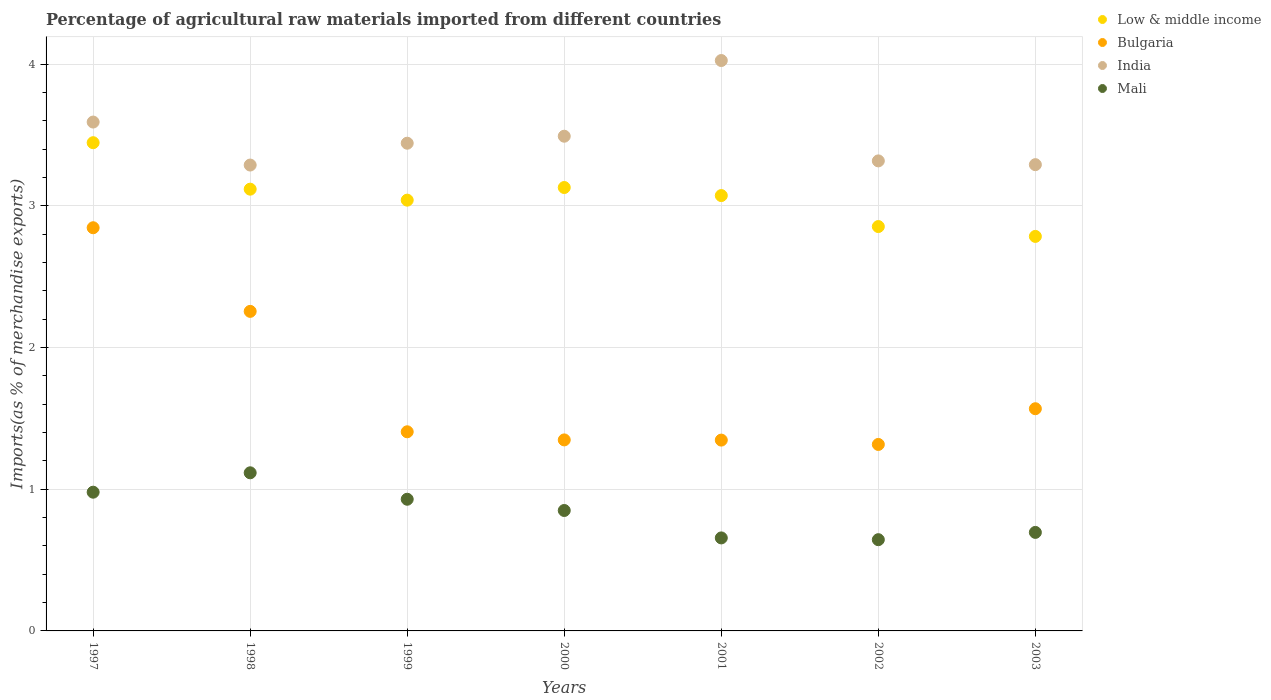Is the number of dotlines equal to the number of legend labels?
Make the answer very short. Yes. What is the percentage of imports to different countries in Bulgaria in 2001?
Your answer should be compact. 1.35. Across all years, what is the maximum percentage of imports to different countries in Mali?
Your answer should be very brief. 1.12. Across all years, what is the minimum percentage of imports to different countries in Bulgaria?
Give a very brief answer. 1.32. What is the total percentage of imports to different countries in Bulgaria in the graph?
Provide a short and direct response. 12.09. What is the difference between the percentage of imports to different countries in Mali in 2000 and that in 2001?
Keep it short and to the point. 0.19. What is the difference between the percentage of imports to different countries in Mali in 1999 and the percentage of imports to different countries in Low & middle income in 2000?
Ensure brevity in your answer.  -2.2. What is the average percentage of imports to different countries in India per year?
Your answer should be compact. 3.49. In the year 2001, what is the difference between the percentage of imports to different countries in India and percentage of imports to different countries in Bulgaria?
Your answer should be compact. 2.68. In how many years, is the percentage of imports to different countries in India greater than 0.2 %?
Offer a very short reply. 7. What is the ratio of the percentage of imports to different countries in Mali in 1997 to that in 1998?
Offer a very short reply. 0.88. Is the percentage of imports to different countries in India in 1997 less than that in 2001?
Keep it short and to the point. Yes. What is the difference between the highest and the second highest percentage of imports to different countries in Bulgaria?
Make the answer very short. 0.59. What is the difference between the highest and the lowest percentage of imports to different countries in Mali?
Offer a terse response. 0.47. In how many years, is the percentage of imports to different countries in Bulgaria greater than the average percentage of imports to different countries in Bulgaria taken over all years?
Your answer should be compact. 2. Is the sum of the percentage of imports to different countries in Mali in 1999 and 2000 greater than the maximum percentage of imports to different countries in India across all years?
Offer a very short reply. No. Is it the case that in every year, the sum of the percentage of imports to different countries in India and percentage of imports to different countries in Mali  is greater than the sum of percentage of imports to different countries in Low & middle income and percentage of imports to different countries in Bulgaria?
Your response must be concise. No. Is it the case that in every year, the sum of the percentage of imports to different countries in Bulgaria and percentage of imports to different countries in India  is greater than the percentage of imports to different countries in Mali?
Your answer should be very brief. Yes. Is the percentage of imports to different countries in Bulgaria strictly greater than the percentage of imports to different countries in Mali over the years?
Offer a very short reply. Yes. How many years are there in the graph?
Offer a terse response. 7. What is the difference between two consecutive major ticks on the Y-axis?
Make the answer very short. 1. Does the graph contain any zero values?
Keep it short and to the point. No. Where does the legend appear in the graph?
Offer a very short reply. Top right. How many legend labels are there?
Keep it short and to the point. 4. What is the title of the graph?
Your answer should be very brief. Percentage of agricultural raw materials imported from different countries. What is the label or title of the Y-axis?
Make the answer very short. Imports(as % of merchandise exports). What is the Imports(as % of merchandise exports) in Low & middle income in 1997?
Make the answer very short. 3.45. What is the Imports(as % of merchandise exports) of Bulgaria in 1997?
Keep it short and to the point. 2.85. What is the Imports(as % of merchandise exports) of India in 1997?
Your response must be concise. 3.59. What is the Imports(as % of merchandise exports) of Mali in 1997?
Your answer should be very brief. 0.98. What is the Imports(as % of merchandise exports) in Low & middle income in 1998?
Make the answer very short. 3.12. What is the Imports(as % of merchandise exports) in Bulgaria in 1998?
Keep it short and to the point. 2.26. What is the Imports(as % of merchandise exports) of India in 1998?
Make the answer very short. 3.29. What is the Imports(as % of merchandise exports) in Mali in 1998?
Give a very brief answer. 1.12. What is the Imports(as % of merchandise exports) in Low & middle income in 1999?
Your answer should be compact. 3.04. What is the Imports(as % of merchandise exports) in Bulgaria in 1999?
Offer a very short reply. 1.41. What is the Imports(as % of merchandise exports) of India in 1999?
Give a very brief answer. 3.44. What is the Imports(as % of merchandise exports) of Mali in 1999?
Make the answer very short. 0.93. What is the Imports(as % of merchandise exports) in Low & middle income in 2000?
Your answer should be very brief. 3.13. What is the Imports(as % of merchandise exports) in Bulgaria in 2000?
Provide a succinct answer. 1.35. What is the Imports(as % of merchandise exports) in India in 2000?
Your answer should be compact. 3.49. What is the Imports(as % of merchandise exports) in Mali in 2000?
Offer a terse response. 0.85. What is the Imports(as % of merchandise exports) of Low & middle income in 2001?
Your answer should be very brief. 3.07. What is the Imports(as % of merchandise exports) of Bulgaria in 2001?
Make the answer very short. 1.35. What is the Imports(as % of merchandise exports) in India in 2001?
Make the answer very short. 4.03. What is the Imports(as % of merchandise exports) in Mali in 2001?
Make the answer very short. 0.66. What is the Imports(as % of merchandise exports) in Low & middle income in 2002?
Offer a terse response. 2.85. What is the Imports(as % of merchandise exports) of Bulgaria in 2002?
Offer a terse response. 1.32. What is the Imports(as % of merchandise exports) in India in 2002?
Give a very brief answer. 3.32. What is the Imports(as % of merchandise exports) in Mali in 2002?
Make the answer very short. 0.64. What is the Imports(as % of merchandise exports) of Low & middle income in 2003?
Offer a very short reply. 2.78. What is the Imports(as % of merchandise exports) in Bulgaria in 2003?
Your answer should be compact. 1.57. What is the Imports(as % of merchandise exports) of India in 2003?
Your response must be concise. 3.29. What is the Imports(as % of merchandise exports) in Mali in 2003?
Your answer should be very brief. 0.7. Across all years, what is the maximum Imports(as % of merchandise exports) in Low & middle income?
Offer a very short reply. 3.45. Across all years, what is the maximum Imports(as % of merchandise exports) of Bulgaria?
Provide a short and direct response. 2.85. Across all years, what is the maximum Imports(as % of merchandise exports) in India?
Your answer should be compact. 4.03. Across all years, what is the maximum Imports(as % of merchandise exports) of Mali?
Offer a very short reply. 1.12. Across all years, what is the minimum Imports(as % of merchandise exports) of Low & middle income?
Provide a succinct answer. 2.78. Across all years, what is the minimum Imports(as % of merchandise exports) in Bulgaria?
Ensure brevity in your answer.  1.32. Across all years, what is the minimum Imports(as % of merchandise exports) in India?
Provide a short and direct response. 3.29. Across all years, what is the minimum Imports(as % of merchandise exports) in Mali?
Offer a terse response. 0.64. What is the total Imports(as % of merchandise exports) in Low & middle income in the graph?
Your answer should be very brief. 21.45. What is the total Imports(as % of merchandise exports) in Bulgaria in the graph?
Offer a terse response. 12.09. What is the total Imports(as % of merchandise exports) of India in the graph?
Give a very brief answer. 24.45. What is the total Imports(as % of merchandise exports) of Mali in the graph?
Make the answer very short. 5.87. What is the difference between the Imports(as % of merchandise exports) of Low & middle income in 1997 and that in 1998?
Your answer should be very brief. 0.33. What is the difference between the Imports(as % of merchandise exports) in Bulgaria in 1997 and that in 1998?
Your answer should be very brief. 0.59. What is the difference between the Imports(as % of merchandise exports) of India in 1997 and that in 1998?
Give a very brief answer. 0.3. What is the difference between the Imports(as % of merchandise exports) in Mali in 1997 and that in 1998?
Offer a very short reply. -0.14. What is the difference between the Imports(as % of merchandise exports) in Low & middle income in 1997 and that in 1999?
Your response must be concise. 0.41. What is the difference between the Imports(as % of merchandise exports) in Bulgaria in 1997 and that in 1999?
Make the answer very short. 1.44. What is the difference between the Imports(as % of merchandise exports) of India in 1997 and that in 1999?
Give a very brief answer. 0.15. What is the difference between the Imports(as % of merchandise exports) of Mali in 1997 and that in 1999?
Keep it short and to the point. 0.05. What is the difference between the Imports(as % of merchandise exports) in Low & middle income in 1997 and that in 2000?
Your answer should be very brief. 0.32. What is the difference between the Imports(as % of merchandise exports) in Bulgaria in 1997 and that in 2000?
Make the answer very short. 1.5. What is the difference between the Imports(as % of merchandise exports) of India in 1997 and that in 2000?
Make the answer very short. 0.1. What is the difference between the Imports(as % of merchandise exports) of Mali in 1997 and that in 2000?
Keep it short and to the point. 0.13. What is the difference between the Imports(as % of merchandise exports) in Low & middle income in 1997 and that in 2001?
Your answer should be very brief. 0.37. What is the difference between the Imports(as % of merchandise exports) of Bulgaria in 1997 and that in 2001?
Your answer should be very brief. 1.5. What is the difference between the Imports(as % of merchandise exports) of India in 1997 and that in 2001?
Your answer should be compact. -0.43. What is the difference between the Imports(as % of merchandise exports) in Mali in 1997 and that in 2001?
Offer a very short reply. 0.32. What is the difference between the Imports(as % of merchandise exports) of Low & middle income in 1997 and that in 2002?
Give a very brief answer. 0.59. What is the difference between the Imports(as % of merchandise exports) in Bulgaria in 1997 and that in 2002?
Keep it short and to the point. 1.53. What is the difference between the Imports(as % of merchandise exports) in India in 1997 and that in 2002?
Your answer should be compact. 0.27. What is the difference between the Imports(as % of merchandise exports) in Mali in 1997 and that in 2002?
Offer a very short reply. 0.34. What is the difference between the Imports(as % of merchandise exports) in Low & middle income in 1997 and that in 2003?
Offer a very short reply. 0.66. What is the difference between the Imports(as % of merchandise exports) of Bulgaria in 1997 and that in 2003?
Offer a very short reply. 1.28. What is the difference between the Imports(as % of merchandise exports) in India in 1997 and that in 2003?
Offer a terse response. 0.3. What is the difference between the Imports(as % of merchandise exports) of Mali in 1997 and that in 2003?
Offer a very short reply. 0.28. What is the difference between the Imports(as % of merchandise exports) of Low & middle income in 1998 and that in 1999?
Provide a succinct answer. 0.08. What is the difference between the Imports(as % of merchandise exports) of Bulgaria in 1998 and that in 1999?
Offer a terse response. 0.85. What is the difference between the Imports(as % of merchandise exports) of India in 1998 and that in 1999?
Provide a short and direct response. -0.15. What is the difference between the Imports(as % of merchandise exports) of Mali in 1998 and that in 1999?
Offer a terse response. 0.19. What is the difference between the Imports(as % of merchandise exports) in Low & middle income in 1998 and that in 2000?
Your answer should be compact. -0.01. What is the difference between the Imports(as % of merchandise exports) in Bulgaria in 1998 and that in 2000?
Provide a short and direct response. 0.91. What is the difference between the Imports(as % of merchandise exports) of India in 1998 and that in 2000?
Offer a very short reply. -0.2. What is the difference between the Imports(as % of merchandise exports) of Mali in 1998 and that in 2000?
Ensure brevity in your answer.  0.27. What is the difference between the Imports(as % of merchandise exports) in Low & middle income in 1998 and that in 2001?
Provide a succinct answer. 0.05. What is the difference between the Imports(as % of merchandise exports) of Bulgaria in 1998 and that in 2001?
Your answer should be compact. 0.91. What is the difference between the Imports(as % of merchandise exports) of India in 1998 and that in 2001?
Offer a very short reply. -0.74. What is the difference between the Imports(as % of merchandise exports) in Mali in 1998 and that in 2001?
Provide a succinct answer. 0.46. What is the difference between the Imports(as % of merchandise exports) in Low & middle income in 1998 and that in 2002?
Ensure brevity in your answer.  0.26. What is the difference between the Imports(as % of merchandise exports) in Bulgaria in 1998 and that in 2002?
Your answer should be very brief. 0.94. What is the difference between the Imports(as % of merchandise exports) in India in 1998 and that in 2002?
Your answer should be very brief. -0.03. What is the difference between the Imports(as % of merchandise exports) of Mali in 1998 and that in 2002?
Offer a terse response. 0.47. What is the difference between the Imports(as % of merchandise exports) of Low & middle income in 1998 and that in 2003?
Offer a very short reply. 0.33. What is the difference between the Imports(as % of merchandise exports) of Bulgaria in 1998 and that in 2003?
Offer a very short reply. 0.69. What is the difference between the Imports(as % of merchandise exports) in India in 1998 and that in 2003?
Give a very brief answer. -0. What is the difference between the Imports(as % of merchandise exports) of Mali in 1998 and that in 2003?
Your response must be concise. 0.42. What is the difference between the Imports(as % of merchandise exports) of Low & middle income in 1999 and that in 2000?
Your answer should be very brief. -0.09. What is the difference between the Imports(as % of merchandise exports) of Bulgaria in 1999 and that in 2000?
Keep it short and to the point. 0.06. What is the difference between the Imports(as % of merchandise exports) of India in 1999 and that in 2000?
Your answer should be compact. -0.05. What is the difference between the Imports(as % of merchandise exports) of Mali in 1999 and that in 2000?
Your response must be concise. 0.08. What is the difference between the Imports(as % of merchandise exports) in Low & middle income in 1999 and that in 2001?
Ensure brevity in your answer.  -0.03. What is the difference between the Imports(as % of merchandise exports) of Bulgaria in 1999 and that in 2001?
Offer a very short reply. 0.06. What is the difference between the Imports(as % of merchandise exports) in India in 1999 and that in 2001?
Provide a succinct answer. -0.58. What is the difference between the Imports(as % of merchandise exports) of Mali in 1999 and that in 2001?
Give a very brief answer. 0.27. What is the difference between the Imports(as % of merchandise exports) in Low & middle income in 1999 and that in 2002?
Offer a very short reply. 0.19. What is the difference between the Imports(as % of merchandise exports) in Bulgaria in 1999 and that in 2002?
Ensure brevity in your answer.  0.09. What is the difference between the Imports(as % of merchandise exports) of India in 1999 and that in 2002?
Your answer should be very brief. 0.12. What is the difference between the Imports(as % of merchandise exports) of Mali in 1999 and that in 2002?
Provide a succinct answer. 0.29. What is the difference between the Imports(as % of merchandise exports) of Low & middle income in 1999 and that in 2003?
Provide a succinct answer. 0.26. What is the difference between the Imports(as % of merchandise exports) in Bulgaria in 1999 and that in 2003?
Your answer should be compact. -0.16. What is the difference between the Imports(as % of merchandise exports) in India in 1999 and that in 2003?
Your answer should be compact. 0.15. What is the difference between the Imports(as % of merchandise exports) in Mali in 1999 and that in 2003?
Keep it short and to the point. 0.23. What is the difference between the Imports(as % of merchandise exports) of Low & middle income in 2000 and that in 2001?
Your answer should be compact. 0.06. What is the difference between the Imports(as % of merchandise exports) of Bulgaria in 2000 and that in 2001?
Make the answer very short. 0. What is the difference between the Imports(as % of merchandise exports) in India in 2000 and that in 2001?
Your response must be concise. -0.53. What is the difference between the Imports(as % of merchandise exports) in Mali in 2000 and that in 2001?
Make the answer very short. 0.19. What is the difference between the Imports(as % of merchandise exports) of Low & middle income in 2000 and that in 2002?
Ensure brevity in your answer.  0.28. What is the difference between the Imports(as % of merchandise exports) in Bulgaria in 2000 and that in 2002?
Make the answer very short. 0.03. What is the difference between the Imports(as % of merchandise exports) of India in 2000 and that in 2002?
Your answer should be very brief. 0.17. What is the difference between the Imports(as % of merchandise exports) of Mali in 2000 and that in 2002?
Make the answer very short. 0.21. What is the difference between the Imports(as % of merchandise exports) in Low & middle income in 2000 and that in 2003?
Give a very brief answer. 0.35. What is the difference between the Imports(as % of merchandise exports) of Bulgaria in 2000 and that in 2003?
Keep it short and to the point. -0.22. What is the difference between the Imports(as % of merchandise exports) in India in 2000 and that in 2003?
Offer a terse response. 0.2. What is the difference between the Imports(as % of merchandise exports) of Mali in 2000 and that in 2003?
Give a very brief answer. 0.15. What is the difference between the Imports(as % of merchandise exports) in Low & middle income in 2001 and that in 2002?
Give a very brief answer. 0.22. What is the difference between the Imports(as % of merchandise exports) of Bulgaria in 2001 and that in 2002?
Offer a very short reply. 0.03. What is the difference between the Imports(as % of merchandise exports) of India in 2001 and that in 2002?
Your response must be concise. 0.71. What is the difference between the Imports(as % of merchandise exports) of Mali in 2001 and that in 2002?
Keep it short and to the point. 0.01. What is the difference between the Imports(as % of merchandise exports) in Low & middle income in 2001 and that in 2003?
Provide a short and direct response. 0.29. What is the difference between the Imports(as % of merchandise exports) of Bulgaria in 2001 and that in 2003?
Give a very brief answer. -0.22. What is the difference between the Imports(as % of merchandise exports) of India in 2001 and that in 2003?
Offer a very short reply. 0.73. What is the difference between the Imports(as % of merchandise exports) in Mali in 2001 and that in 2003?
Offer a terse response. -0.04. What is the difference between the Imports(as % of merchandise exports) in Low & middle income in 2002 and that in 2003?
Provide a succinct answer. 0.07. What is the difference between the Imports(as % of merchandise exports) of Bulgaria in 2002 and that in 2003?
Give a very brief answer. -0.25. What is the difference between the Imports(as % of merchandise exports) in India in 2002 and that in 2003?
Offer a terse response. 0.03. What is the difference between the Imports(as % of merchandise exports) of Mali in 2002 and that in 2003?
Give a very brief answer. -0.05. What is the difference between the Imports(as % of merchandise exports) of Low & middle income in 1997 and the Imports(as % of merchandise exports) of Bulgaria in 1998?
Your answer should be very brief. 1.19. What is the difference between the Imports(as % of merchandise exports) in Low & middle income in 1997 and the Imports(as % of merchandise exports) in India in 1998?
Make the answer very short. 0.16. What is the difference between the Imports(as % of merchandise exports) of Low & middle income in 1997 and the Imports(as % of merchandise exports) of Mali in 1998?
Offer a terse response. 2.33. What is the difference between the Imports(as % of merchandise exports) in Bulgaria in 1997 and the Imports(as % of merchandise exports) in India in 1998?
Your answer should be compact. -0.44. What is the difference between the Imports(as % of merchandise exports) of Bulgaria in 1997 and the Imports(as % of merchandise exports) of Mali in 1998?
Offer a very short reply. 1.73. What is the difference between the Imports(as % of merchandise exports) in India in 1997 and the Imports(as % of merchandise exports) in Mali in 1998?
Ensure brevity in your answer.  2.48. What is the difference between the Imports(as % of merchandise exports) in Low & middle income in 1997 and the Imports(as % of merchandise exports) in Bulgaria in 1999?
Your answer should be very brief. 2.04. What is the difference between the Imports(as % of merchandise exports) of Low & middle income in 1997 and the Imports(as % of merchandise exports) of India in 1999?
Your answer should be very brief. 0. What is the difference between the Imports(as % of merchandise exports) in Low & middle income in 1997 and the Imports(as % of merchandise exports) in Mali in 1999?
Give a very brief answer. 2.52. What is the difference between the Imports(as % of merchandise exports) in Bulgaria in 1997 and the Imports(as % of merchandise exports) in India in 1999?
Provide a short and direct response. -0.6. What is the difference between the Imports(as % of merchandise exports) of Bulgaria in 1997 and the Imports(as % of merchandise exports) of Mali in 1999?
Provide a short and direct response. 1.92. What is the difference between the Imports(as % of merchandise exports) in India in 1997 and the Imports(as % of merchandise exports) in Mali in 1999?
Your answer should be compact. 2.66. What is the difference between the Imports(as % of merchandise exports) of Low & middle income in 1997 and the Imports(as % of merchandise exports) of Bulgaria in 2000?
Offer a terse response. 2.1. What is the difference between the Imports(as % of merchandise exports) of Low & middle income in 1997 and the Imports(as % of merchandise exports) of India in 2000?
Provide a succinct answer. -0.05. What is the difference between the Imports(as % of merchandise exports) in Low & middle income in 1997 and the Imports(as % of merchandise exports) in Mali in 2000?
Your answer should be very brief. 2.6. What is the difference between the Imports(as % of merchandise exports) of Bulgaria in 1997 and the Imports(as % of merchandise exports) of India in 2000?
Offer a very short reply. -0.65. What is the difference between the Imports(as % of merchandise exports) of Bulgaria in 1997 and the Imports(as % of merchandise exports) of Mali in 2000?
Your answer should be very brief. 2. What is the difference between the Imports(as % of merchandise exports) in India in 1997 and the Imports(as % of merchandise exports) in Mali in 2000?
Provide a succinct answer. 2.74. What is the difference between the Imports(as % of merchandise exports) of Low & middle income in 1997 and the Imports(as % of merchandise exports) of Bulgaria in 2001?
Make the answer very short. 2.1. What is the difference between the Imports(as % of merchandise exports) in Low & middle income in 1997 and the Imports(as % of merchandise exports) in India in 2001?
Provide a short and direct response. -0.58. What is the difference between the Imports(as % of merchandise exports) in Low & middle income in 1997 and the Imports(as % of merchandise exports) in Mali in 2001?
Offer a terse response. 2.79. What is the difference between the Imports(as % of merchandise exports) in Bulgaria in 1997 and the Imports(as % of merchandise exports) in India in 2001?
Offer a very short reply. -1.18. What is the difference between the Imports(as % of merchandise exports) of Bulgaria in 1997 and the Imports(as % of merchandise exports) of Mali in 2001?
Offer a very short reply. 2.19. What is the difference between the Imports(as % of merchandise exports) of India in 1997 and the Imports(as % of merchandise exports) of Mali in 2001?
Your answer should be very brief. 2.94. What is the difference between the Imports(as % of merchandise exports) in Low & middle income in 1997 and the Imports(as % of merchandise exports) in Bulgaria in 2002?
Your answer should be very brief. 2.13. What is the difference between the Imports(as % of merchandise exports) in Low & middle income in 1997 and the Imports(as % of merchandise exports) in India in 2002?
Provide a short and direct response. 0.13. What is the difference between the Imports(as % of merchandise exports) of Low & middle income in 1997 and the Imports(as % of merchandise exports) of Mali in 2002?
Your answer should be compact. 2.8. What is the difference between the Imports(as % of merchandise exports) in Bulgaria in 1997 and the Imports(as % of merchandise exports) in India in 2002?
Offer a very short reply. -0.47. What is the difference between the Imports(as % of merchandise exports) of Bulgaria in 1997 and the Imports(as % of merchandise exports) of Mali in 2002?
Give a very brief answer. 2.2. What is the difference between the Imports(as % of merchandise exports) in India in 1997 and the Imports(as % of merchandise exports) in Mali in 2002?
Provide a succinct answer. 2.95. What is the difference between the Imports(as % of merchandise exports) of Low & middle income in 1997 and the Imports(as % of merchandise exports) of Bulgaria in 2003?
Provide a short and direct response. 1.88. What is the difference between the Imports(as % of merchandise exports) in Low & middle income in 1997 and the Imports(as % of merchandise exports) in India in 2003?
Make the answer very short. 0.16. What is the difference between the Imports(as % of merchandise exports) of Low & middle income in 1997 and the Imports(as % of merchandise exports) of Mali in 2003?
Keep it short and to the point. 2.75. What is the difference between the Imports(as % of merchandise exports) in Bulgaria in 1997 and the Imports(as % of merchandise exports) in India in 2003?
Keep it short and to the point. -0.45. What is the difference between the Imports(as % of merchandise exports) in Bulgaria in 1997 and the Imports(as % of merchandise exports) in Mali in 2003?
Your answer should be compact. 2.15. What is the difference between the Imports(as % of merchandise exports) of India in 1997 and the Imports(as % of merchandise exports) of Mali in 2003?
Provide a short and direct response. 2.9. What is the difference between the Imports(as % of merchandise exports) of Low & middle income in 1998 and the Imports(as % of merchandise exports) of Bulgaria in 1999?
Keep it short and to the point. 1.71. What is the difference between the Imports(as % of merchandise exports) of Low & middle income in 1998 and the Imports(as % of merchandise exports) of India in 1999?
Make the answer very short. -0.32. What is the difference between the Imports(as % of merchandise exports) of Low & middle income in 1998 and the Imports(as % of merchandise exports) of Mali in 1999?
Give a very brief answer. 2.19. What is the difference between the Imports(as % of merchandise exports) in Bulgaria in 1998 and the Imports(as % of merchandise exports) in India in 1999?
Provide a short and direct response. -1.19. What is the difference between the Imports(as % of merchandise exports) of Bulgaria in 1998 and the Imports(as % of merchandise exports) of Mali in 1999?
Your answer should be compact. 1.33. What is the difference between the Imports(as % of merchandise exports) of India in 1998 and the Imports(as % of merchandise exports) of Mali in 1999?
Keep it short and to the point. 2.36. What is the difference between the Imports(as % of merchandise exports) in Low & middle income in 1998 and the Imports(as % of merchandise exports) in Bulgaria in 2000?
Give a very brief answer. 1.77. What is the difference between the Imports(as % of merchandise exports) in Low & middle income in 1998 and the Imports(as % of merchandise exports) in India in 2000?
Offer a terse response. -0.37. What is the difference between the Imports(as % of merchandise exports) in Low & middle income in 1998 and the Imports(as % of merchandise exports) in Mali in 2000?
Make the answer very short. 2.27. What is the difference between the Imports(as % of merchandise exports) in Bulgaria in 1998 and the Imports(as % of merchandise exports) in India in 2000?
Your answer should be very brief. -1.24. What is the difference between the Imports(as % of merchandise exports) in Bulgaria in 1998 and the Imports(as % of merchandise exports) in Mali in 2000?
Your response must be concise. 1.41. What is the difference between the Imports(as % of merchandise exports) of India in 1998 and the Imports(as % of merchandise exports) of Mali in 2000?
Your answer should be very brief. 2.44. What is the difference between the Imports(as % of merchandise exports) in Low & middle income in 1998 and the Imports(as % of merchandise exports) in Bulgaria in 2001?
Your response must be concise. 1.77. What is the difference between the Imports(as % of merchandise exports) of Low & middle income in 1998 and the Imports(as % of merchandise exports) of India in 2001?
Ensure brevity in your answer.  -0.91. What is the difference between the Imports(as % of merchandise exports) of Low & middle income in 1998 and the Imports(as % of merchandise exports) of Mali in 2001?
Your response must be concise. 2.46. What is the difference between the Imports(as % of merchandise exports) of Bulgaria in 1998 and the Imports(as % of merchandise exports) of India in 2001?
Give a very brief answer. -1.77. What is the difference between the Imports(as % of merchandise exports) of Bulgaria in 1998 and the Imports(as % of merchandise exports) of Mali in 2001?
Your answer should be very brief. 1.6. What is the difference between the Imports(as % of merchandise exports) in India in 1998 and the Imports(as % of merchandise exports) in Mali in 2001?
Offer a very short reply. 2.63. What is the difference between the Imports(as % of merchandise exports) of Low & middle income in 1998 and the Imports(as % of merchandise exports) of Bulgaria in 2002?
Make the answer very short. 1.8. What is the difference between the Imports(as % of merchandise exports) of Low & middle income in 1998 and the Imports(as % of merchandise exports) of India in 2002?
Your answer should be very brief. -0.2. What is the difference between the Imports(as % of merchandise exports) in Low & middle income in 1998 and the Imports(as % of merchandise exports) in Mali in 2002?
Provide a short and direct response. 2.47. What is the difference between the Imports(as % of merchandise exports) of Bulgaria in 1998 and the Imports(as % of merchandise exports) of India in 2002?
Make the answer very short. -1.06. What is the difference between the Imports(as % of merchandise exports) of Bulgaria in 1998 and the Imports(as % of merchandise exports) of Mali in 2002?
Offer a terse response. 1.61. What is the difference between the Imports(as % of merchandise exports) of India in 1998 and the Imports(as % of merchandise exports) of Mali in 2002?
Your answer should be very brief. 2.64. What is the difference between the Imports(as % of merchandise exports) of Low & middle income in 1998 and the Imports(as % of merchandise exports) of Bulgaria in 2003?
Make the answer very short. 1.55. What is the difference between the Imports(as % of merchandise exports) of Low & middle income in 1998 and the Imports(as % of merchandise exports) of India in 2003?
Keep it short and to the point. -0.17. What is the difference between the Imports(as % of merchandise exports) in Low & middle income in 1998 and the Imports(as % of merchandise exports) in Mali in 2003?
Your answer should be very brief. 2.42. What is the difference between the Imports(as % of merchandise exports) in Bulgaria in 1998 and the Imports(as % of merchandise exports) in India in 2003?
Provide a short and direct response. -1.04. What is the difference between the Imports(as % of merchandise exports) in Bulgaria in 1998 and the Imports(as % of merchandise exports) in Mali in 2003?
Offer a very short reply. 1.56. What is the difference between the Imports(as % of merchandise exports) in India in 1998 and the Imports(as % of merchandise exports) in Mali in 2003?
Ensure brevity in your answer.  2.59. What is the difference between the Imports(as % of merchandise exports) in Low & middle income in 1999 and the Imports(as % of merchandise exports) in Bulgaria in 2000?
Offer a very short reply. 1.69. What is the difference between the Imports(as % of merchandise exports) in Low & middle income in 1999 and the Imports(as % of merchandise exports) in India in 2000?
Your answer should be compact. -0.45. What is the difference between the Imports(as % of merchandise exports) of Low & middle income in 1999 and the Imports(as % of merchandise exports) of Mali in 2000?
Your answer should be very brief. 2.19. What is the difference between the Imports(as % of merchandise exports) of Bulgaria in 1999 and the Imports(as % of merchandise exports) of India in 2000?
Keep it short and to the point. -2.09. What is the difference between the Imports(as % of merchandise exports) of Bulgaria in 1999 and the Imports(as % of merchandise exports) of Mali in 2000?
Make the answer very short. 0.56. What is the difference between the Imports(as % of merchandise exports) of India in 1999 and the Imports(as % of merchandise exports) of Mali in 2000?
Offer a terse response. 2.59. What is the difference between the Imports(as % of merchandise exports) of Low & middle income in 1999 and the Imports(as % of merchandise exports) of Bulgaria in 2001?
Keep it short and to the point. 1.69. What is the difference between the Imports(as % of merchandise exports) in Low & middle income in 1999 and the Imports(as % of merchandise exports) in India in 2001?
Your answer should be very brief. -0.99. What is the difference between the Imports(as % of merchandise exports) in Low & middle income in 1999 and the Imports(as % of merchandise exports) in Mali in 2001?
Your response must be concise. 2.38. What is the difference between the Imports(as % of merchandise exports) in Bulgaria in 1999 and the Imports(as % of merchandise exports) in India in 2001?
Your answer should be very brief. -2.62. What is the difference between the Imports(as % of merchandise exports) in Bulgaria in 1999 and the Imports(as % of merchandise exports) in Mali in 2001?
Make the answer very short. 0.75. What is the difference between the Imports(as % of merchandise exports) of India in 1999 and the Imports(as % of merchandise exports) of Mali in 2001?
Keep it short and to the point. 2.79. What is the difference between the Imports(as % of merchandise exports) of Low & middle income in 1999 and the Imports(as % of merchandise exports) of Bulgaria in 2002?
Offer a very short reply. 1.72. What is the difference between the Imports(as % of merchandise exports) in Low & middle income in 1999 and the Imports(as % of merchandise exports) in India in 2002?
Your response must be concise. -0.28. What is the difference between the Imports(as % of merchandise exports) of Low & middle income in 1999 and the Imports(as % of merchandise exports) of Mali in 2002?
Ensure brevity in your answer.  2.4. What is the difference between the Imports(as % of merchandise exports) of Bulgaria in 1999 and the Imports(as % of merchandise exports) of India in 2002?
Your answer should be very brief. -1.91. What is the difference between the Imports(as % of merchandise exports) in Bulgaria in 1999 and the Imports(as % of merchandise exports) in Mali in 2002?
Provide a succinct answer. 0.76. What is the difference between the Imports(as % of merchandise exports) in India in 1999 and the Imports(as % of merchandise exports) in Mali in 2002?
Your response must be concise. 2.8. What is the difference between the Imports(as % of merchandise exports) in Low & middle income in 1999 and the Imports(as % of merchandise exports) in Bulgaria in 2003?
Keep it short and to the point. 1.47. What is the difference between the Imports(as % of merchandise exports) in Low & middle income in 1999 and the Imports(as % of merchandise exports) in India in 2003?
Ensure brevity in your answer.  -0.25. What is the difference between the Imports(as % of merchandise exports) of Low & middle income in 1999 and the Imports(as % of merchandise exports) of Mali in 2003?
Your response must be concise. 2.35. What is the difference between the Imports(as % of merchandise exports) of Bulgaria in 1999 and the Imports(as % of merchandise exports) of India in 2003?
Your answer should be compact. -1.89. What is the difference between the Imports(as % of merchandise exports) of Bulgaria in 1999 and the Imports(as % of merchandise exports) of Mali in 2003?
Provide a short and direct response. 0.71. What is the difference between the Imports(as % of merchandise exports) in India in 1999 and the Imports(as % of merchandise exports) in Mali in 2003?
Your answer should be compact. 2.75. What is the difference between the Imports(as % of merchandise exports) in Low & middle income in 2000 and the Imports(as % of merchandise exports) in Bulgaria in 2001?
Provide a short and direct response. 1.78. What is the difference between the Imports(as % of merchandise exports) of Low & middle income in 2000 and the Imports(as % of merchandise exports) of India in 2001?
Provide a short and direct response. -0.9. What is the difference between the Imports(as % of merchandise exports) of Low & middle income in 2000 and the Imports(as % of merchandise exports) of Mali in 2001?
Keep it short and to the point. 2.47. What is the difference between the Imports(as % of merchandise exports) in Bulgaria in 2000 and the Imports(as % of merchandise exports) in India in 2001?
Give a very brief answer. -2.68. What is the difference between the Imports(as % of merchandise exports) of Bulgaria in 2000 and the Imports(as % of merchandise exports) of Mali in 2001?
Make the answer very short. 0.69. What is the difference between the Imports(as % of merchandise exports) of India in 2000 and the Imports(as % of merchandise exports) of Mali in 2001?
Offer a very short reply. 2.84. What is the difference between the Imports(as % of merchandise exports) of Low & middle income in 2000 and the Imports(as % of merchandise exports) of Bulgaria in 2002?
Ensure brevity in your answer.  1.81. What is the difference between the Imports(as % of merchandise exports) in Low & middle income in 2000 and the Imports(as % of merchandise exports) in India in 2002?
Your response must be concise. -0.19. What is the difference between the Imports(as % of merchandise exports) in Low & middle income in 2000 and the Imports(as % of merchandise exports) in Mali in 2002?
Your response must be concise. 2.49. What is the difference between the Imports(as % of merchandise exports) in Bulgaria in 2000 and the Imports(as % of merchandise exports) in India in 2002?
Your answer should be compact. -1.97. What is the difference between the Imports(as % of merchandise exports) in Bulgaria in 2000 and the Imports(as % of merchandise exports) in Mali in 2002?
Offer a terse response. 0.7. What is the difference between the Imports(as % of merchandise exports) of India in 2000 and the Imports(as % of merchandise exports) of Mali in 2002?
Your response must be concise. 2.85. What is the difference between the Imports(as % of merchandise exports) in Low & middle income in 2000 and the Imports(as % of merchandise exports) in Bulgaria in 2003?
Your answer should be compact. 1.56. What is the difference between the Imports(as % of merchandise exports) of Low & middle income in 2000 and the Imports(as % of merchandise exports) of India in 2003?
Your answer should be compact. -0.16. What is the difference between the Imports(as % of merchandise exports) in Low & middle income in 2000 and the Imports(as % of merchandise exports) in Mali in 2003?
Offer a very short reply. 2.43. What is the difference between the Imports(as % of merchandise exports) in Bulgaria in 2000 and the Imports(as % of merchandise exports) in India in 2003?
Offer a very short reply. -1.94. What is the difference between the Imports(as % of merchandise exports) of Bulgaria in 2000 and the Imports(as % of merchandise exports) of Mali in 2003?
Your answer should be very brief. 0.65. What is the difference between the Imports(as % of merchandise exports) of India in 2000 and the Imports(as % of merchandise exports) of Mali in 2003?
Keep it short and to the point. 2.8. What is the difference between the Imports(as % of merchandise exports) of Low & middle income in 2001 and the Imports(as % of merchandise exports) of Bulgaria in 2002?
Provide a short and direct response. 1.76. What is the difference between the Imports(as % of merchandise exports) of Low & middle income in 2001 and the Imports(as % of merchandise exports) of India in 2002?
Your response must be concise. -0.24. What is the difference between the Imports(as % of merchandise exports) in Low & middle income in 2001 and the Imports(as % of merchandise exports) in Mali in 2002?
Ensure brevity in your answer.  2.43. What is the difference between the Imports(as % of merchandise exports) in Bulgaria in 2001 and the Imports(as % of merchandise exports) in India in 2002?
Make the answer very short. -1.97. What is the difference between the Imports(as % of merchandise exports) in Bulgaria in 2001 and the Imports(as % of merchandise exports) in Mali in 2002?
Provide a succinct answer. 0.7. What is the difference between the Imports(as % of merchandise exports) of India in 2001 and the Imports(as % of merchandise exports) of Mali in 2002?
Provide a short and direct response. 3.38. What is the difference between the Imports(as % of merchandise exports) in Low & middle income in 2001 and the Imports(as % of merchandise exports) in Bulgaria in 2003?
Keep it short and to the point. 1.5. What is the difference between the Imports(as % of merchandise exports) in Low & middle income in 2001 and the Imports(as % of merchandise exports) in India in 2003?
Your answer should be compact. -0.22. What is the difference between the Imports(as % of merchandise exports) of Low & middle income in 2001 and the Imports(as % of merchandise exports) of Mali in 2003?
Your answer should be compact. 2.38. What is the difference between the Imports(as % of merchandise exports) of Bulgaria in 2001 and the Imports(as % of merchandise exports) of India in 2003?
Make the answer very short. -1.94. What is the difference between the Imports(as % of merchandise exports) in Bulgaria in 2001 and the Imports(as % of merchandise exports) in Mali in 2003?
Keep it short and to the point. 0.65. What is the difference between the Imports(as % of merchandise exports) of India in 2001 and the Imports(as % of merchandise exports) of Mali in 2003?
Your answer should be compact. 3.33. What is the difference between the Imports(as % of merchandise exports) in Low & middle income in 2002 and the Imports(as % of merchandise exports) in Bulgaria in 2003?
Your response must be concise. 1.29. What is the difference between the Imports(as % of merchandise exports) of Low & middle income in 2002 and the Imports(as % of merchandise exports) of India in 2003?
Keep it short and to the point. -0.44. What is the difference between the Imports(as % of merchandise exports) in Low & middle income in 2002 and the Imports(as % of merchandise exports) in Mali in 2003?
Keep it short and to the point. 2.16. What is the difference between the Imports(as % of merchandise exports) in Bulgaria in 2002 and the Imports(as % of merchandise exports) in India in 2003?
Your answer should be very brief. -1.97. What is the difference between the Imports(as % of merchandise exports) in Bulgaria in 2002 and the Imports(as % of merchandise exports) in Mali in 2003?
Keep it short and to the point. 0.62. What is the difference between the Imports(as % of merchandise exports) in India in 2002 and the Imports(as % of merchandise exports) in Mali in 2003?
Provide a short and direct response. 2.62. What is the average Imports(as % of merchandise exports) of Low & middle income per year?
Give a very brief answer. 3.06. What is the average Imports(as % of merchandise exports) in Bulgaria per year?
Your response must be concise. 1.73. What is the average Imports(as % of merchandise exports) of India per year?
Offer a very short reply. 3.49. What is the average Imports(as % of merchandise exports) in Mali per year?
Ensure brevity in your answer.  0.84. In the year 1997, what is the difference between the Imports(as % of merchandise exports) in Low & middle income and Imports(as % of merchandise exports) in Bulgaria?
Your answer should be very brief. 0.6. In the year 1997, what is the difference between the Imports(as % of merchandise exports) in Low & middle income and Imports(as % of merchandise exports) in India?
Make the answer very short. -0.15. In the year 1997, what is the difference between the Imports(as % of merchandise exports) in Low & middle income and Imports(as % of merchandise exports) in Mali?
Offer a very short reply. 2.47. In the year 1997, what is the difference between the Imports(as % of merchandise exports) in Bulgaria and Imports(as % of merchandise exports) in India?
Ensure brevity in your answer.  -0.75. In the year 1997, what is the difference between the Imports(as % of merchandise exports) of Bulgaria and Imports(as % of merchandise exports) of Mali?
Your answer should be very brief. 1.87. In the year 1997, what is the difference between the Imports(as % of merchandise exports) of India and Imports(as % of merchandise exports) of Mali?
Provide a succinct answer. 2.61. In the year 1998, what is the difference between the Imports(as % of merchandise exports) of Low & middle income and Imports(as % of merchandise exports) of Bulgaria?
Offer a very short reply. 0.86. In the year 1998, what is the difference between the Imports(as % of merchandise exports) of Low & middle income and Imports(as % of merchandise exports) of India?
Provide a short and direct response. -0.17. In the year 1998, what is the difference between the Imports(as % of merchandise exports) in Low & middle income and Imports(as % of merchandise exports) in Mali?
Your response must be concise. 2. In the year 1998, what is the difference between the Imports(as % of merchandise exports) in Bulgaria and Imports(as % of merchandise exports) in India?
Your response must be concise. -1.03. In the year 1998, what is the difference between the Imports(as % of merchandise exports) of Bulgaria and Imports(as % of merchandise exports) of Mali?
Provide a short and direct response. 1.14. In the year 1998, what is the difference between the Imports(as % of merchandise exports) of India and Imports(as % of merchandise exports) of Mali?
Provide a succinct answer. 2.17. In the year 1999, what is the difference between the Imports(as % of merchandise exports) in Low & middle income and Imports(as % of merchandise exports) in Bulgaria?
Ensure brevity in your answer.  1.64. In the year 1999, what is the difference between the Imports(as % of merchandise exports) in Low & middle income and Imports(as % of merchandise exports) in India?
Your answer should be compact. -0.4. In the year 1999, what is the difference between the Imports(as % of merchandise exports) of Low & middle income and Imports(as % of merchandise exports) of Mali?
Your answer should be very brief. 2.11. In the year 1999, what is the difference between the Imports(as % of merchandise exports) of Bulgaria and Imports(as % of merchandise exports) of India?
Your response must be concise. -2.04. In the year 1999, what is the difference between the Imports(as % of merchandise exports) of Bulgaria and Imports(as % of merchandise exports) of Mali?
Provide a short and direct response. 0.48. In the year 1999, what is the difference between the Imports(as % of merchandise exports) of India and Imports(as % of merchandise exports) of Mali?
Offer a terse response. 2.51. In the year 2000, what is the difference between the Imports(as % of merchandise exports) of Low & middle income and Imports(as % of merchandise exports) of Bulgaria?
Keep it short and to the point. 1.78. In the year 2000, what is the difference between the Imports(as % of merchandise exports) of Low & middle income and Imports(as % of merchandise exports) of India?
Keep it short and to the point. -0.36. In the year 2000, what is the difference between the Imports(as % of merchandise exports) of Low & middle income and Imports(as % of merchandise exports) of Mali?
Your response must be concise. 2.28. In the year 2000, what is the difference between the Imports(as % of merchandise exports) in Bulgaria and Imports(as % of merchandise exports) in India?
Ensure brevity in your answer.  -2.14. In the year 2000, what is the difference between the Imports(as % of merchandise exports) in Bulgaria and Imports(as % of merchandise exports) in Mali?
Provide a succinct answer. 0.5. In the year 2000, what is the difference between the Imports(as % of merchandise exports) of India and Imports(as % of merchandise exports) of Mali?
Make the answer very short. 2.64. In the year 2001, what is the difference between the Imports(as % of merchandise exports) in Low & middle income and Imports(as % of merchandise exports) in Bulgaria?
Offer a very short reply. 1.73. In the year 2001, what is the difference between the Imports(as % of merchandise exports) in Low & middle income and Imports(as % of merchandise exports) in India?
Make the answer very short. -0.95. In the year 2001, what is the difference between the Imports(as % of merchandise exports) of Low & middle income and Imports(as % of merchandise exports) of Mali?
Keep it short and to the point. 2.42. In the year 2001, what is the difference between the Imports(as % of merchandise exports) in Bulgaria and Imports(as % of merchandise exports) in India?
Offer a very short reply. -2.68. In the year 2001, what is the difference between the Imports(as % of merchandise exports) of Bulgaria and Imports(as % of merchandise exports) of Mali?
Offer a very short reply. 0.69. In the year 2001, what is the difference between the Imports(as % of merchandise exports) of India and Imports(as % of merchandise exports) of Mali?
Your response must be concise. 3.37. In the year 2002, what is the difference between the Imports(as % of merchandise exports) of Low & middle income and Imports(as % of merchandise exports) of Bulgaria?
Give a very brief answer. 1.54. In the year 2002, what is the difference between the Imports(as % of merchandise exports) of Low & middle income and Imports(as % of merchandise exports) of India?
Make the answer very short. -0.46. In the year 2002, what is the difference between the Imports(as % of merchandise exports) in Low & middle income and Imports(as % of merchandise exports) in Mali?
Your response must be concise. 2.21. In the year 2002, what is the difference between the Imports(as % of merchandise exports) in Bulgaria and Imports(as % of merchandise exports) in India?
Offer a very short reply. -2. In the year 2002, what is the difference between the Imports(as % of merchandise exports) of Bulgaria and Imports(as % of merchandise exports) of Mali?
Keep it short and to the point. 0.67. In the year 2002, what is the difference between the Imports(as % of merchandise exports) in India and Imports(as % of merchandise exports) in Mali?
Offer a very short reply. 2.67. In the year 2003, what is the difference between the Imports(as % of merchandise exports) in Low & middle income and Imports(as % of merchandise exports) in Bulgaria?
Your answer should be very brief. 1.22. In the year 2003, what is the difference between the Imports(as % of merchandise exports) of Low & middle income and Imports(as % of merchandise exports) of India?
Offer a terse response. -0.51. In the year 2003, what is the difference between the Imports(as % of merchandise exports) of Low & middle income and Imports(as % of merchandise exports) of Mali?
Your answer should be compact. 2.09. In the year 2003, what is the difference between the Imports(as % of merchandise exports) in Bulgaria and Imports(as % of merchandise exports) in India?
Make the answer very short. -1.72. In the year 2003, what is the difference between the Imports(as % of merchandise exports) in Bulgaria and Imports(as % of merchandise exports) in Mali?
Provide a succinct answer. 0.87. In the year 2003, what is the difference between the Imports(as % of merchandise exports) of India and Imports(as % of merchandise exports) of Mali?
Provide a short and direct response. 2.6. What is the ratio of the Imports(as % of merchandise exports) of Low & middle income in 1997 to that in 1998?
Your response must be concise. 1.11. What is the ratio of the Imports(as % of merchandise exports) of Bulgaria in 1997 to that in 1998?
Offer a very short reply. 1.26. What is the ratio of the Imports(as % of merchandise exports) in India in 1997 to that in 1998?
Your answer should be compact. 1.09. What is the ratio of the Imports(as % of merchandise exports) of Mali in 1997 to that in 1998?
Ensure brevity in your answer.  0.88. What is the ratio of the Imports(as % of merchandise exports) of Low & middle income in 1997 to that in 1999?
Your answer should be very brief. 1.13. What is the ratio of the Imports(as % of merchandise exports) of Bulgaria in 1997 to that in 1999?
Your answer should be compact. 2.02. What is the ratio of the Imports(as % of merchandise exports) of India in 1997 to that in 1999?
Your answer should be compact. 1.04. What is the ratio of the Imports(as % of merchandise exports) in Mali in 1997 to that in 1999?
Provide a short and direct response. 1.05. What is the ratio of the Imports(as % of merchandise exports) of Low & middle income in 1997 to that in 2000?
Give a very brief answer. 1.1. What is the ratio of the Imports(as % of merchandise exports) in Bulgaria in 1997 to that in 2000?
Your answer should be very brief. 2.11. What is the ratio of the Imports(as % of merchandise exports) of India in 1997 to that in 2000?
Offer a very short reply. 1.03. What is the ratio of the Imports(as % of merchandise exports) in Mali in 1997 to that in 2000?
Your response must be concise. 1.15. What is the ratio of the Imports(as % of merchandise exports) in Low & middle income in 1997 to that in 2001?
Offer a very short reply. 1.12. What is the ratio of the Imports(as % of merchandise exports) in Bulgaria in 1997 to that in 2001?
Give a very brief answer. 2.11. What is the ratio of the Imports(as % of merchandise exports) of India in 1997 to that in 2001?
Ensure brevity in your answer.  0.89. What is the ratio of the Imports(as % of merchandise exports) in Mali in 1997 to that in 2001?
Your answer should be very brief. 1.49. What is the ratio of the Imports(as % of merchandise exports) of Low & middle income in 1997 to that in 2002?
Your response must be concise. 1.21. What is the ratio of the Imports(as % of merchandise exports) of Bulgaria in 1997 to that in 2002?
Your answer should be very brief. 2.16. What is the ratio of the Imports(as % of merchandise exports) in India in 1997 to that in 2002?
Give a very brief answer. 1.08. What is the ratio of the Imports(as % of merchandise exports) in Mali in 1997 to that in 2002?
Ensure brevity in your answer.  1.52. What is the ratio of the Imports(as % of merchandise exports) of Low & middle income in 1997 to that in 2003?
Make the answer very short. 1.24. What is the ratio of the Imports(as % of merchandise exports) of Bulgaria in 1997 to that in 2003?
Offer a terse response. 1.81. What is the ratio of the Imports(as % of merchandise exports) of India in 1997 to that in 2003?
Your answer should be compact. 1.09. What is the ratio of the Imports(as % of merchandise exports) of Mali in 1997 to that in 2003?
Offer a terse response. 1.41. What is the ratio of the Imports(as % of merchandise exports) in Low & middle income in 1998 to that in 1999?
Your response must be concise. 1.03. What is the ratio of the Imports(as % of merchandise exports) in Bulgaria in 1998 to that in 1999?
Provide a short and direct response. 1.6. What is the ratio of the Imports(as % of merchandise exports) in India in 1998 to that in 1999?
Your answer should be very brief. 0.96. What is the ratio of the Imports(as % of merchandise exports) in Mali in 1998 to that in 1999?
Ensure brevity in your answer.  1.2. What is the ratio of the Imports(as % of merchandise exports) of Low & middle income in 1998 to that in 2000?
Offer a very short reply. 1. What is the ratio of the Imports(as % of merchandise exports) of Bulgaria in 1998 to that in 2000?
Your response must be concise. 1.67. What is the ratio of the Imports(as % of merchandise exports) in India in 1998 to that in 2000?
Your answer should be compact. 0.94. What is the ratio of the Imports(as % of merchandise exports) of Mali in 1998 to that in 2000?
Your answer should be very brief. 1.31. What is the ratio of the Imports(as % of merchandise exports) of Low & middle income in 1998 to that in 2001?
Ensure brevity in your answer.  1.01. What is the ratio of the Imports(as % of merchandise exports) of Bulgaria in 1998 to that in 2001?
Your response must be concise. 1.67. What is the ratio of the Imports(as % of merchandise exports) in India in 1998 to that in 2001?
Provide a succinct answer. 0.82. What is the ratio of the Imports(as % of merchandise exports) of Mali in 1998 to that in 2001?
Keep it short and to the point. 1.7. What is the ratio of the Imports(as % of merchandise exports) of Low & middle income in 1998 to that in 2002?
Give a very brief answer. 1.09. What is the ratio of the Imports(as % of merchandise exports) of Bulgaria in 1998 to that in 2002?
Keep it short and to the point. 1.71. What is the ratio of the Imports(as % of merchandise exports) of India in 1998 to that in 2002?
Give a very brief answer. 0.99. What is the ratio of the Imports(as % of merchandise exports) of Mali in 1998 to that in 2002?
Your answer should be very brief. 1.73. What is the ratio of the Imports(as % of merchandise exports) in Low & middle income in 1998 to that in 2003?
Ensure brevity in your answer.  1.12. What is the ratio of the Imports(as % of merchandise exports) in Bulgaria in 1998 to that in 2003?
Make the answer very short. 1.44. What is the ratio of the Imports(as % of merchandise exports) in Mali in 1998 to that in 2003?
Offer a very short reply. 1.6. What is the ratio of the Imports(as % of merchandise exports) of Low & middle income in 1999 to that in 2000?
Your answer should be compact. 0.97. What is the ratio of the Imports(as % of merchandise exports) of Bulgaria in 1999 to that in 2000?
Your answer should be compact. 1.04. What is the ratio of the Imports(as % of merchandise exports) in India in 1999 to that in 2000?
Provide a succinct answer. 0.99. What is the ratio of the Imports(as % of merchandise exports) in Mali in 1999 to that in 2000?
Your answer should be compact. 1.09. What is the ratio of the Imports(as % of merchandise exports) of Bulgaria in 1999 to that in 2001?
Your response must be concise. 1.04. What is the ratio of the Imports(as % of merchandise exports) in India in 1999 to that in 2001?
Offer a very short reply. 0.85. What is the ratio of the Imports(as % of merchandise exports) of Mali in 1999 to that in 2001?
Offer a very short reply. 1.42. What is the ratio of the Imports(as % of merchandise exports) of Low & middle income in 1999 to that in 2002?
Offer a terse response. 1.07. What is the ratio of the Imports(as % of merchandise exports) in Bulgaria in 1999 to that in 2002?
Make the answer very short. 1.07. What is the ratio of the Imports(as % of merchandise exports) of India in 1999 to that in 2002?
Ensure brevity in your answer.  1.04. What is the ratio of the Imports(as % of merchandise exports) in Mali in 1999 to that in 2002?
Your response must be concise. 1.44. What is the ratio of the Imports(as % of merchandise exports) of Low & middle income in 1999 to that in 2003?
Ensure brevity in your answer.  1.09. What is the ratio of the Imports(as % of merchandise exports) in Bulgaria in 1999 to that in 2003?
Provide a short and direct response. 0.9. What is the ratio of the Imports(as % of merchandise exports) in India in 1999 to that in 2003?
Your response must be concise. 1.05. What is the ratio of the Imports(as % of merchandise exports) of Mali in 1999 to that in 2003?
Make the answer very short. 1.34. What is the ratio of the Imports(as % of merchandise exports) in Low & middle income in 2000 to that in 2001?
Make the answer very short. 1.02. What is the ratio of the Imports(as % of merchandise exports) of India in 2000 to that in 2001?
Offer a terse response. 0.87. What is the ratio of the Imports(as % of merchandise exports) in Mali in 2000 to that in 2001?
Offer a terse response. 1.29. What is the ratio of the Imports(as % of merchandise exports) of Low & middle income in 2000 to that in 2002?
Provide a succinct answer. 1.1. What is the ratio of the Imports(as % of merchandise exports) of Bulgaria in 2000 to that in 2002?
Provide a short and direct response. 1.02. What is the ratio of the Imports(as % of merchandise exports) in India in 2000 to that in 2002?
Provide a succinct answer. 1.05. What is the ratio of the Imports(as % of merchandise exports) of Mali in 2000 to that in 2002?
Make the answer very short. 1.32. What is the ratio of the Imports(as % of merchandise exports) of Low & middle income in 2000 to that in 2003?
Ensure brevity in your answer.  1.12. What is the ratio of the Imports(as % of merchandise exports) of Bulgaria in 2000 to that in 2003?
Ensure brevity in your answer.  0.86. What is the ratio of the Imports(as % of merchandise exports) in India in 2000 to that in 2003?
Give a very brief answer. 1.06. What is the ratio of the Imports(as % of merchandise exports) in Mali in 2000 to that in 2003?
Offer a terse response. 1.22. What is the ratio of the Imports(as % of merchandise exports) in Low & middle income in 2001 to that in 2002?
Offer a very short reply. 1.08. What is the ratio of the Imports(as % of merchandise exports) of Bulgaria in 2001 to that in 2002?
Your answer should be compact. 1.02. What is the ratio of the Imports(as % of merchandise exports) of India in 2001 to that in 2002?
Give a very brief answer. 1.21. What is the ratio of the Imports(as % of merchandise exports) of Mali in 2001 to that in 2002?
Offer a very short reply. 1.02. What is the ratio of the Imports(as % of merchandise exports) of Low & middle income in 2001 to that in 2003?
Give a very brief answer. 1.1. What is the ratio of the Imports(as % of merchandise exports) of Bulgaria in 2001 to that in 2003?
Give a very brief answer. 0.86. What is the ratio of the Imports(as % of merchandise exports) in India in 2001 to that in 2003?
Offer a terse response. 1.22. What is the ratio of the Imports(as % of merchandise exports) in Mali in 2001 to that in 2003?
Your answer should be very brief. 0.94. What is the ratio of the Imports(as % of merchandise exports) in Bulgaria in 2002 to that in 2003?
Your answer should be compact. 0.84. What is the ratio of the Imports(as % of merchandise exports) of Mali in 2002 to that in 2003?
Provide a succinct answer. 0.93. What is the difference between the highest and the second highest Imports(as % of merchandise exports) of Low & middle income?
Offer a very short reply. 0.32. What is the difference between the highest and the second highest Imports(as % of merchandise exports) of Bulgaria?
Your answer should be very brief. 0.59. What is the difference between the highest and the second highest Imports(as % of merchandise exports) in India?
Provide a succinct answer. 0.43. What is the difference between the highest and the second highest Imports(as % of merchandise exports) of Mali?
Give a very brief answer. 0.14. What is the difference between the highest and the lowest Imports(as % of merchandise exports) of Low & middle income?
Offer a very short reply. 0.66. What is the difference between the highest and the lowest Imports(as % of merchandise exports) in Bulgaria?
Offer a very short reply. 1.53. What is the difference between the highest and the lowest Imports(as % of merchandise exports) of India?
Offer a terse response. 0.74. What is the difference between the highest and the lowest Imports(as % of merchandise exports) of Mali?
Provide a short and direct response. 0.47. 